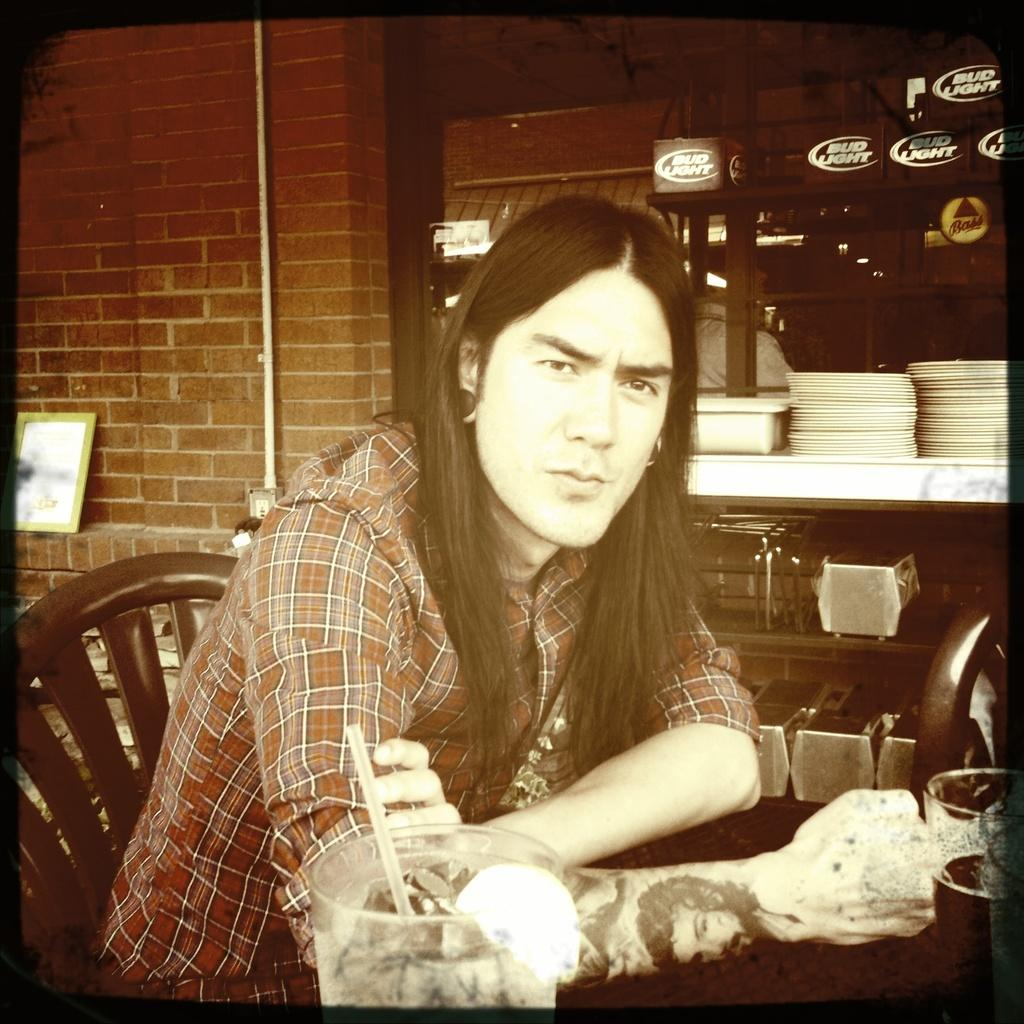What is the person in the image doing? The person is sitting in a chair. What is in front of the person? There is a table in front of the person. How many glasses are on the table? There are two glasses on the table. What else can be seen in the background of the image? There are other objects visible in the background. What type of dinosaurs can be seen playing with rings in the image? There are no dinosaurs or rings present in the image. 